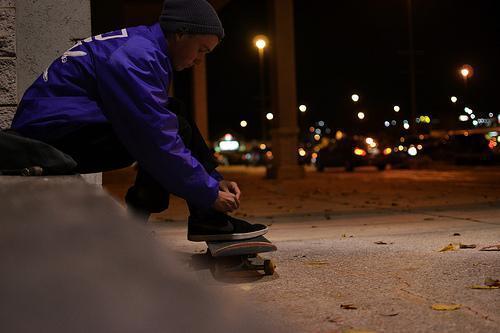How many people are there?
Give a very brief answer. 1. 